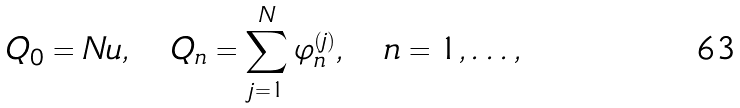<formula> <loc_0><loc_0><loc_500><loc_500>Q _ { 0 } = N u , \quad Q _ { n } = \sum _ { j = 1 } ^ { N } \varphi _ { n } ^ { ( j ) } , \quad n = 1 , \dots ,</formula> 